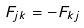<formula> <loc_0><loc_0><loc_500><loc_500>F _ { j k } = - F _ { k j }</formula> 